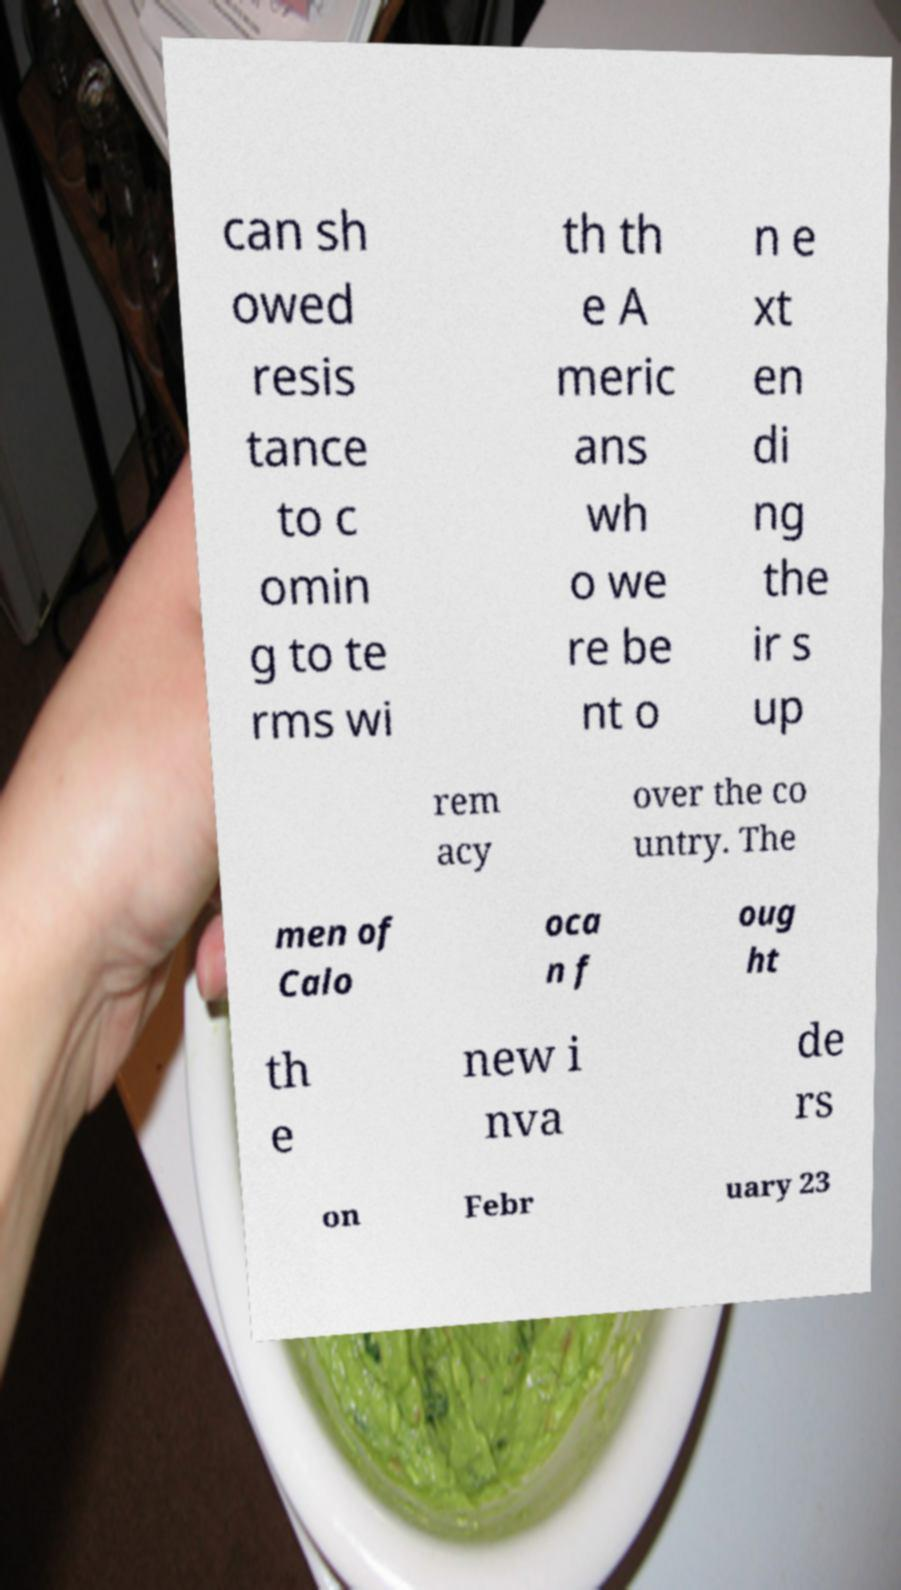Could you extract and type out the text from this image? can sh owed resis tance to c omin g to te rms wi th th e A meric ans wh o we re be nt o n e xt en di ng the ir s up rem acy over the co untry. The men of Calo oca n f oug ht th e new i nva de rs on Febr uary 23 